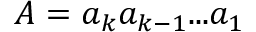<formula> <loc_0><loc_0><loc_500><loc_500>A = { a _ { k } } { a _ { k - 1 } } \dots { a _ { 1 } }</formula> 